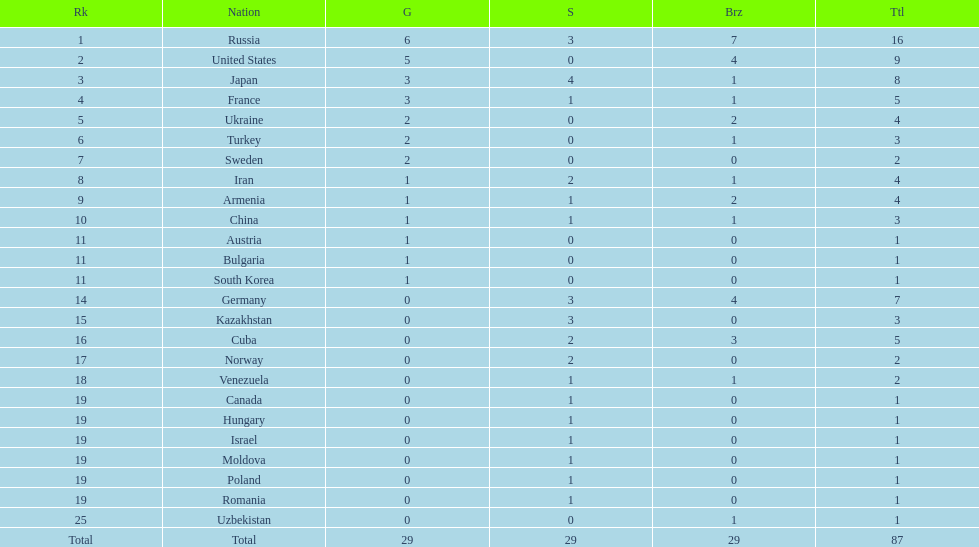What is the number of gold medals won by both japan and france? 3. 